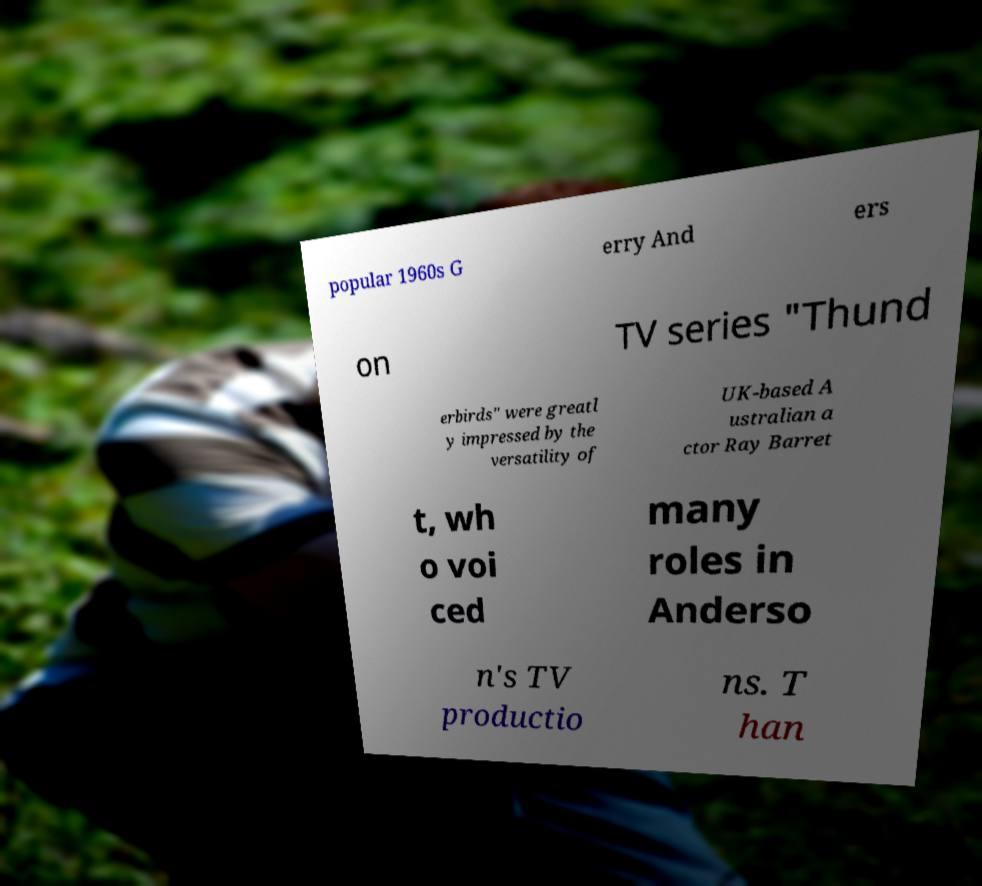Can you read and provide the text displayed in the image?This photo seems to have some interesting text. Can you extract and type it out for me? popular 1960s G erry And ers on TV series "Thund erbirds" were greatl y impressed by the versatility of UK-based A ustralian a ctor Ray Barret t, wh o voi ced many roles in Anderso n's TV productio ns. T han 